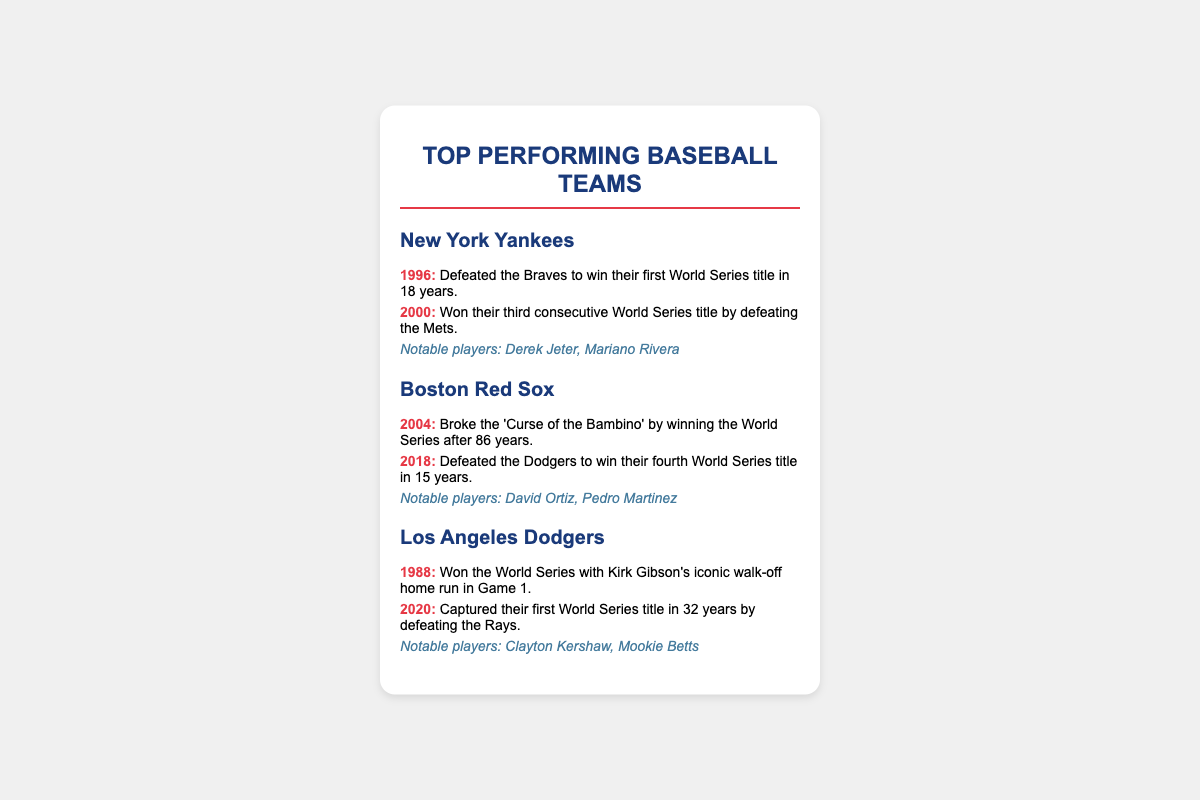What year did the New York Yankees win their first World Series title in 18 years? The document states the Yankees won their first title in 1996 after an 18-year drought.
Answer: 1996 Who broke the 'Curse of the Bambino'? The document indicates that the Boston Red Sox broke this curse.
Answer: Boston Red Sox What year did the Los Angeles Dodgers capture their first World Series title in 32 years? The document mentions that the Dodgers achieved this in 2020.
Answer: 2020 Which team won the World Series in 2000? According to the document, the Yankees won the World Series in that year.
Answer: New York Yankees What notable player is associated with the Boston Red Sox? The document lists David Ortiz as a notable player for this team.
Answer: David Ortiz How many years after their previous title did the Yankees win in 2000? The document explains that they won their third consecutive title, hence it was only one year after their previous win in 1999.
Answer: 1 year Which team had a memorable highlight featuring Kirk Gibson? The document states that Kirk Gibson's iconic home run highlight is associated with the Dodgers.
Answer: Los Angeles Dodgers What is the highlight of the Red Sox's 2004 achievement? The document states they broke the 'Curse of the Bambino' by winning the World Series that year.
Answer: Broke the 'Curse of the Bambino' 